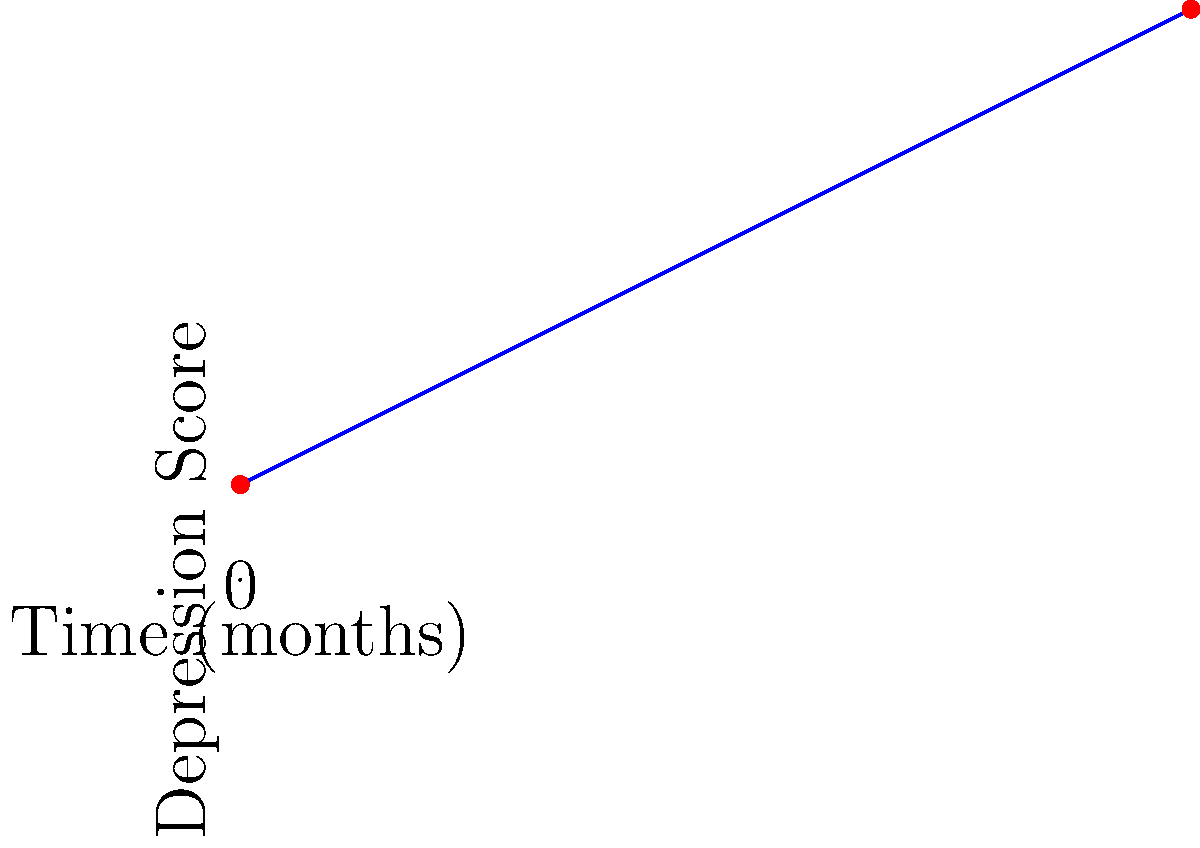In a longitudinal study on depression, the trend line for a patient's depression scores over 10 months is shown above. Estimate the angle of inclination of this trend line to the nearest degree. To estimate the angle of inclination, we can follow these steps:

1) Identify two points on the line. We can use the start and end points:
   (0, 1) and (10, 6)

2) Calculate the rise and run:
   Rise = 6 - 1 = 5
   Run = 10 - 0 = 10

3) Calculate the slope:
   Slope = Rise / Run = 5 / 10 = 0.5

4) The angle of inclination is the arctangent of the slope:
   $$\theta = \arctan(0.5)$$

5) Convert from radians to degrees:
   $$\theta = \arctan(0.5) \cdot \frac{180}{\pi} \approx 26.57°$$

6) Rounding to the nearest degree:
   $$\theta \approx 27°$$

This angle indicates the rate of change in the patient's depression scores over time, with a higher angle suggesting a more rapid increase in depression severity.
Answer: 27° 